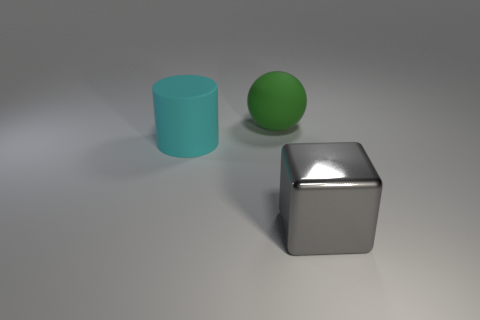Add 2 cylinders. How many objects exist? 5 Subtract all cubes. How many objects are left? 2 Add 3 big balls. How many big balls exist? 4 Subtract 1 cyan cylinders. How many objects are left? 2 Subtract all big yellow metal things. Subtract all large metallic blocks. How many objects are left? 2 Add 2 green rubber spheres. How many green rubber spheres are left? 3 